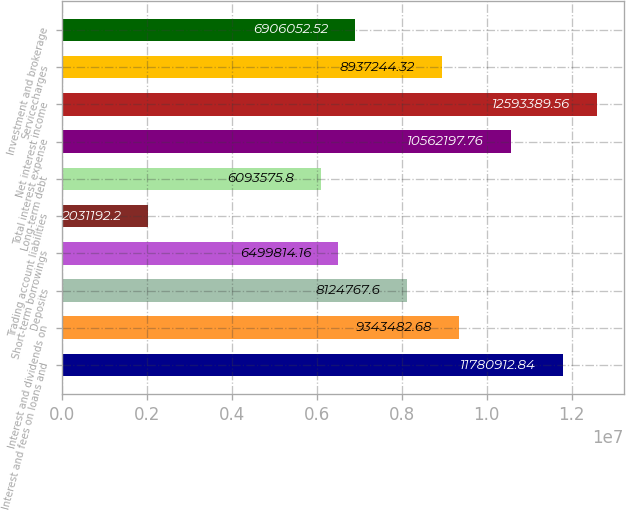Convert chart. <chart><loc_0><loc_0><loc_500><loc_500><bar_chart><fcel>Interest and fees on loans and<fcel>Interest and dividends on<fcel>Deposits<fcel>Short-term borrowings<fcel>Trading account liabilities<fcel>Long-term debt<fcel>Total interest expense<fcel>Net interest income<fcel>Servicecharges<fcel>Investment and brokerage<nl><fcel>1.17809e+07<fcel>9.34348e+06<fcel>8.12477e+06<fcel>6.49981e+06<fcel>2.03119e+06<fcel>6.09358e+06<fcel>1.05622e+07<fcel>1.25934e+07<fcel>8.93724e+06<fcel>6.90605e+06<nl></chart> 